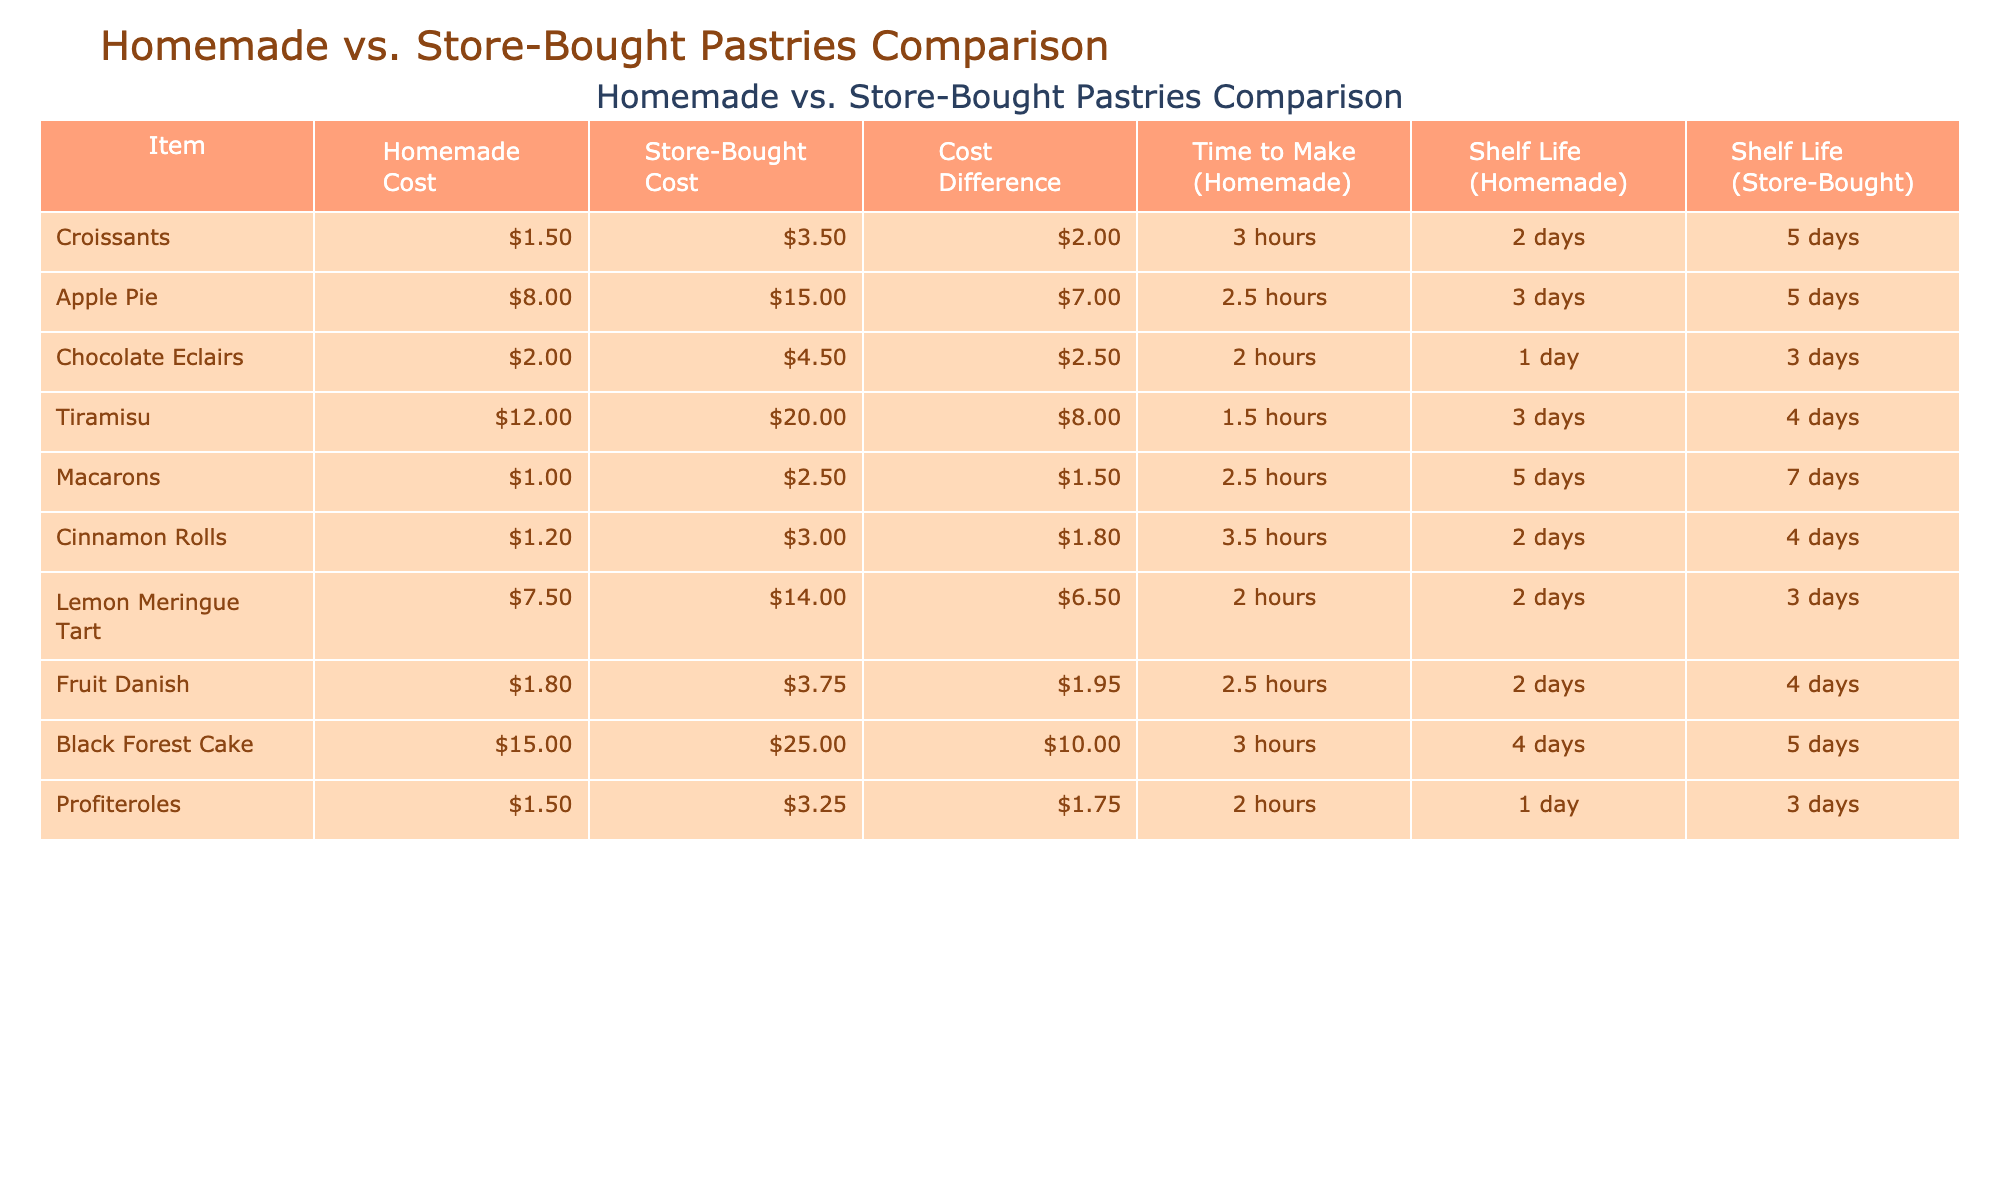What is the cost difference for Apple Pie? The cost for Apple Pie in the store is $15.00, and the homemade cost is $8.00. Therefore, the cost difference is $15.00 - $8.00 = $7.00.
Answer: $7.00 How much time does it take to make Cinnamon Rolls? The time to make Cinnamon Rolls is directly listed in the "Time to Make (Homemade)" column. It is stated as 3.5 hours.
Answer: 3.5 hours Are Tiramisu pastries cheaper when homemade? The homemade cost for Tiramisu is $12.00, while the store-bought cost is $20.00. Since $12.00 is less than $20.00, Tiramisu is indeed cheaper when homemade.
Answer: Yes What is the shelf life of Macarons compared to Fruit Danish? The shelf life for Macarons is 5 days, while for Fruit Danish it is 2 days. Since 5 days is greater than 2 days, Macarons have a longer shelf life.
Answer: 5 days for Macarons, 2 days for Fruit Danish What is the total cost of making Croissants and Chocolate Eclairs at home? The homemade cost of Croissants is $1.50 and Chocolate Eclairs is $2.00. Adding these together gives $1.50 + $2.00 = $3.50.
Answer: $3.50 Is the homemade cost of Black Forest Cake higher than that of Lemon Meringue Tart? The homemade cost for Black Forest Cake is $15.00, while for Lemon Meringue Tart it is $7.50. Since $15.00 is greater than $7.50, the statement is true.
Answer: Yes What is the average homemade cost of the pastries listed? The total homemade cost of all pastries is $1.50 + $8.00 + $2.00 + $12.00 + $1.00 + $1.20 + $7.50 + $1.80 + $15.00 + $1.50 = $50.50. There are 10 total items, so the average is $50.50 / 10 = $5.05.
Answer: $5.05 Which pastry has the longest shelf life among store-bought options? The shelf life for store-bought options includes 5 days for Croissants, Apple Pie, and Black Forest Cake; 4 days for Tiramisu and Cinnamon Rolls; and 3 days for Lemon Meringue Tart and Chocolate Eclairs. The longest shelf life is 5 days.
Answer: 5 days 